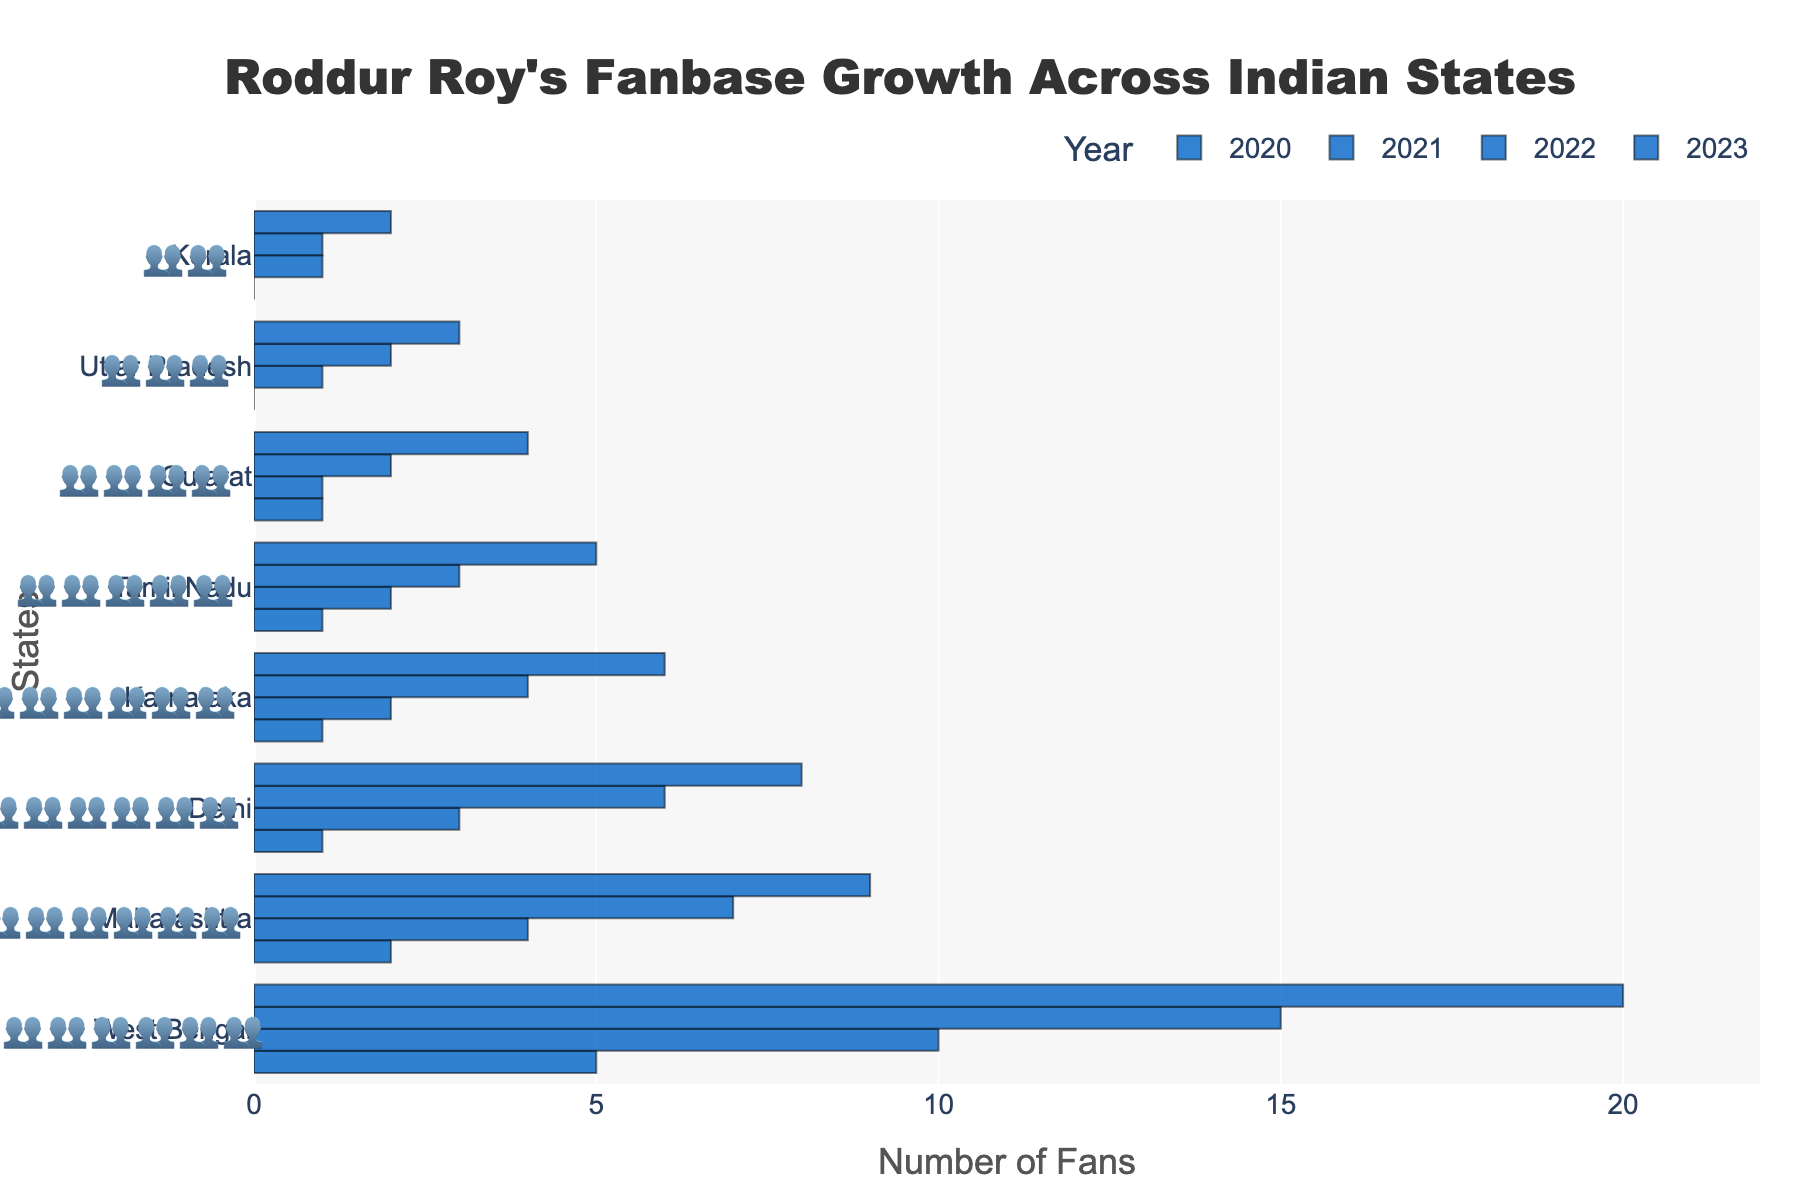How many fans did Roddur Roy have in West Bengal in 2020? According to the figure, the number of fans in West Bengal in 2020 is represented by the bar in 2020. From the bar, it is clear that it corresponds to the value 5. Therefore, in 2020, Roddur Roy had 5 fans in West Bengal.
Answer: 5 Which state saw the largest increase in the number of fans from 2020 to 2023? By examining the heights of the bars for each state between 2020 and 2023, we see the largest increase in West Bengal. The number grew from 5 in 2020 to 20 in 2023, making it a 15 fan increase, which is the highest among all states.
Answer: West Bengal What is the total number of fans across all states in 2023? To find the total number of fans across all states in 2023, sum the values for each state in 2023: 20 (West Bengal) + 9 (Maharashtra) + 8 (Delhi) + 6 (Karnataka) + 5 (Tamil Nadu) + 4 (Gujarat) + 3 (Uttar Pradesh) + 2 (Kerala). The total is 57.
Answer: 57 Which year had the least number of fans in Delhi? Checking the values for Delhi from 2020 to 2023 in the figure, we see that Delhi had 1, 3, 6, and 8 fans respectively. Thus, 2020, with 1 fan, is the year with the least number of fans.
Answer: 2020 Between Tamil Nadu and Karnataka in 2022, which state had more fans, and by how many? For the year 2022, Tamil Nadu had 3 fans, while Karnataka had 4 fans. Comparing these numbers, Karnataka had more fans by 1.
Answer: Karnataka, by 1 What is the average number of fans for Kerala from 2020 to 2023? To calculate the average, sum the numbers for Kerala over the years and divide by the number of years. The numbers are 0 (2020), 1 (2021), 1 (2022), and 2 (2023): Sum = 0 + 1 + 1 + 2 = 4; Average = 4/4 = 1.
Answer: 1 How many more fans did West Bengal have than Uttar Pradesh in 2023? According to the plot, West Bengal had 20 fans and Uttar Pradesh had 3 fans in 2023. The difference is 20 - 3 = 17 fans.
Answer: 17 In which state did the number of fans double from 2021 to 2022? Checking the values from 2021 to 2022 for each state, in Karnataka, the number doubled from 2 to 4. Similarly, in Maharashtra, it increased from 4 to 7, which isn't exactly doubling. So, Karnataka is where the fans doubled.
Answer: Karnataka What is the total increment of fans in Gujarat from 2020 to 2023? To find the increment, subtract the number of fans in 2020 from the number of fans in 2023 for Gujarat: 4 (2023) - 1 (2020) = 3.
Answer: 3 Which state had the smallest total increase in fan count between 2020 and 2023? By checking the differences for each state between 2020 and 2023, Kerala had: 2 - 0 = 2; hence, Kerala had the smallest increase, with an increase in the number of 2 fans.
Answer: Kerala 